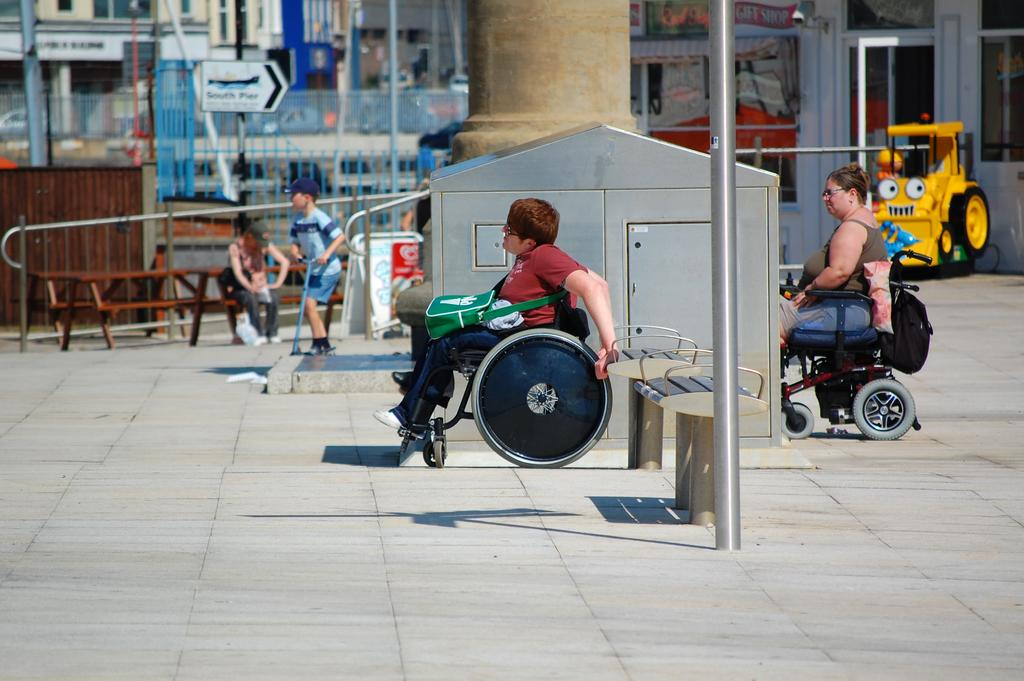How many people are in the image? There is a group of people in the image, but the exact number cannot be determined from the provided facts. What can be seen in the background of the image? There is a fence, poles, and buildings in the background of the image. What type of ear is visible on the fence in the image? There is no ear present in the image, as the facts only mention a fence in the background. 